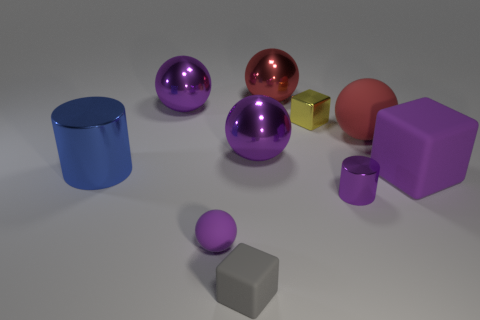Is the number of rubber spheres on the left side of the red metallic sphere the same as the number of yellow metal cubes in front of the small purple rubber sphere?
Keep it short and to the point. No. How many red rubber spheres are the same size as the purple matte cube?
Provide a short and direct response. 1. How many purple things are shiny spheres or big metal objects?
Provide a succinct answer. 2. Are there an equal number of tiny yellow metal blocks that are behind the tiny yellow metal thing and small gray cubes?
Your response must be concise. No. There is a red thing to the left of the yellow cube; what size is it?
Offer a terse response. Large. How many other small shiny objects are the same shape as the tiny yellow object?
Your answer should be compact. 0. What is the material of the large object that is both to the left of the small matte block and on the right side of the large blue metallic object?
Your response must be concise. Metal. Does the tiny purple ball have the same material as the yellow cube?
Offer a very short reply. No. How many cyan metal objects are there?
Provide a succinct answer. 0. There is a tiny block that is behind the small block that is in front of the purple rubber thing left of the large cube; what color is it?
Offer a terse response. Yellow. 